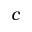<formula> <loc_0><loc_0><loc_500><loc_500>c</formula> 